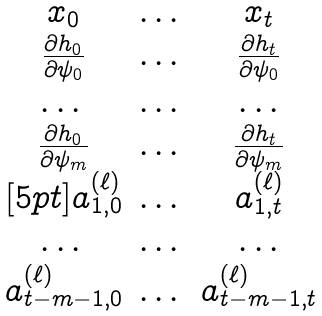Convert formula to latex. <formula><loc_0><loc_0><loc_500><loc_500>\begin{matrix} x _ { 0 } & \dots & x _ { t } \\ \frac { \partial h _ { 0 } } { \partial \psi _ { 0 } } & \dots & \frac { \partial h _ { t } } { \partial \psi _ { 0 } } \\ \dots & \dots & \dots \\ \frac { \partial h _ { 0 } } { \partial \psi _ { m } } & \dots & \frac { \partial h _ { t } } { \partial \psi _ { m } } \\ [ 5 p t ] a ^ { ( \ell ) } _ { 1 , 0 } & \dots & a ^ { ( \ell ) } _ { 1 , t } \\ \dots & \dots & \dots \\ a ^ { ( \ell ) } _ { t - m - 1 , 0 } & \dots & a ^ { ( \ell ) } _ { t - m - 1 , t } \\ \end{matrix}</formula> 